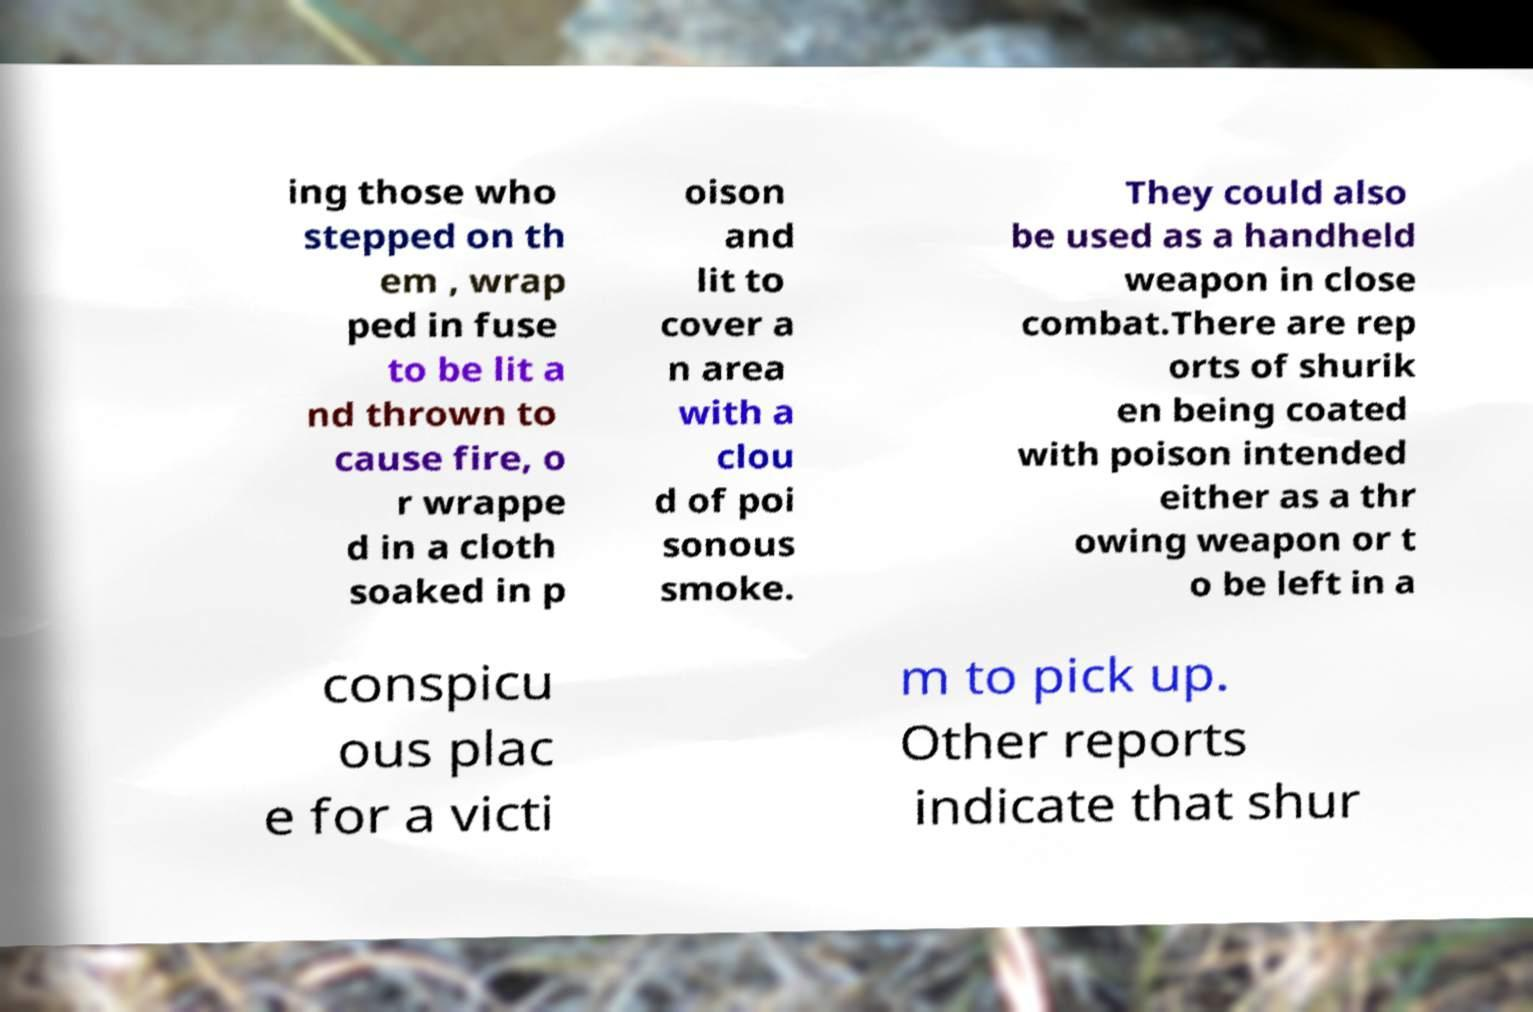Please read and relay the text visible in this image. What does it say? ing those who stepped on th em , wrap ped in fuse to be lit a nd thrown to cause fire, o r wrappe d in a cloth soaked in p oison and lit to cover a n area with a clou d of poi sonous smoke. They could also be used as a handheld weapon in close combat.There are rep orts of shurik en being coated with poison intended either as a thr owing weapon or t o be left in a conspicu ous plac e for a victi m to pick up. Other reports indicate that shur 